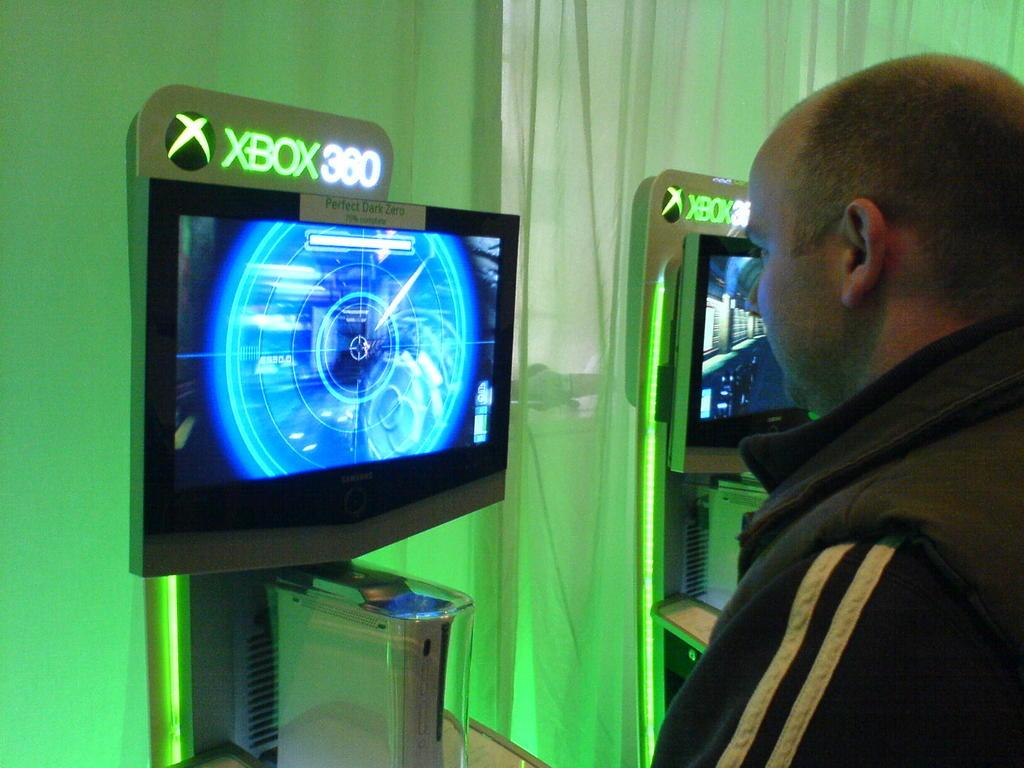<image>
Write a terse but informative summary of the picture. A person stands and plays an Xbox 360 in a green room. 